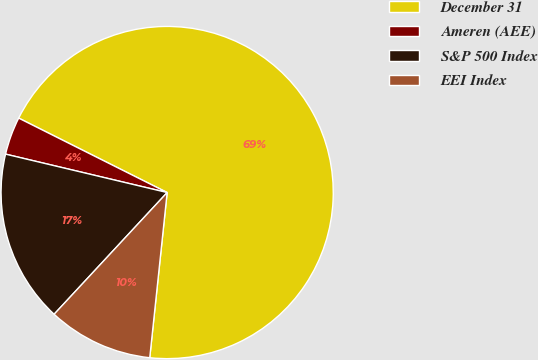Convert chart to OTSL. <chart><loc_0><loc_0><loc_500><loc_500><pie_chart><fcel>December 31<fcel>Ameren (AEE)<fcel>S&P 500 Index<fcel>EEI Index<nl><fcel>69.27%<fcel>3.68%<fcel>16.8%<fcel>10.24%<nl></chart> 